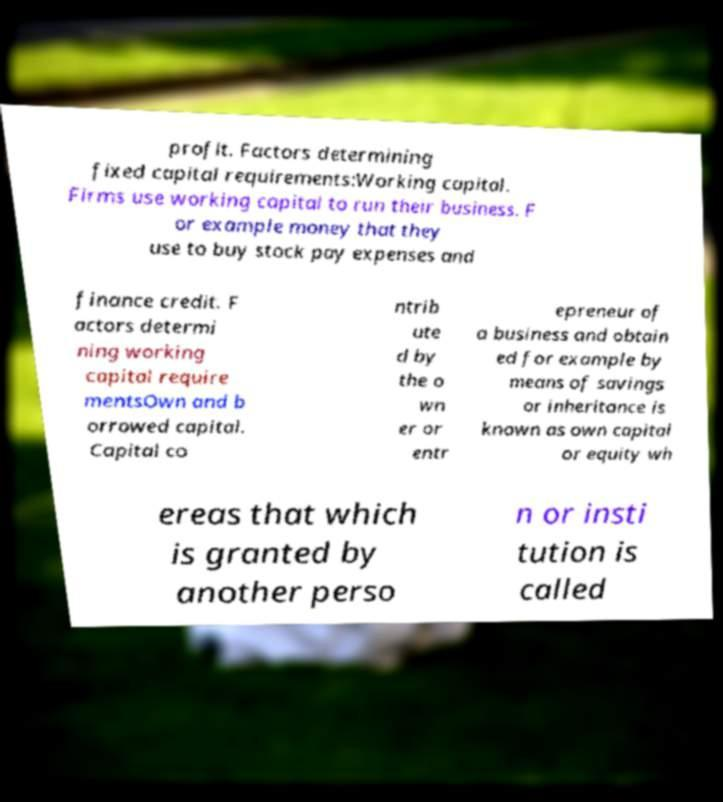Could you extract and type out the text from this image? profit. Factors determining fixed capital requirements:Working capital. Firms use working capital to run their business. F or example money that they use to buy stock pay expenses and finance credit. F actors determi ning working capital require mentsOwn and b orrowed capital. Capital co ntrib ute d by the o wn er or entr epreneur of a business and obtain ed for example by means of savings or inheritance is known as own capital or equity wh ereas that which is granted by another perso n or insti tution is called 